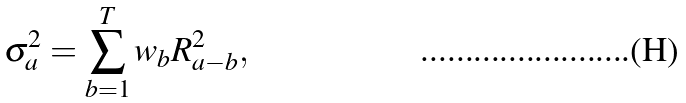<formula> <loc_0><loc_0><loc_500><loc_500>\sigma _ { a } ^ { 2 } = \sum _ { b = 1 } ^ { T } w _ { b } R _ { a - b } ^ { 2 } ,</formula> 